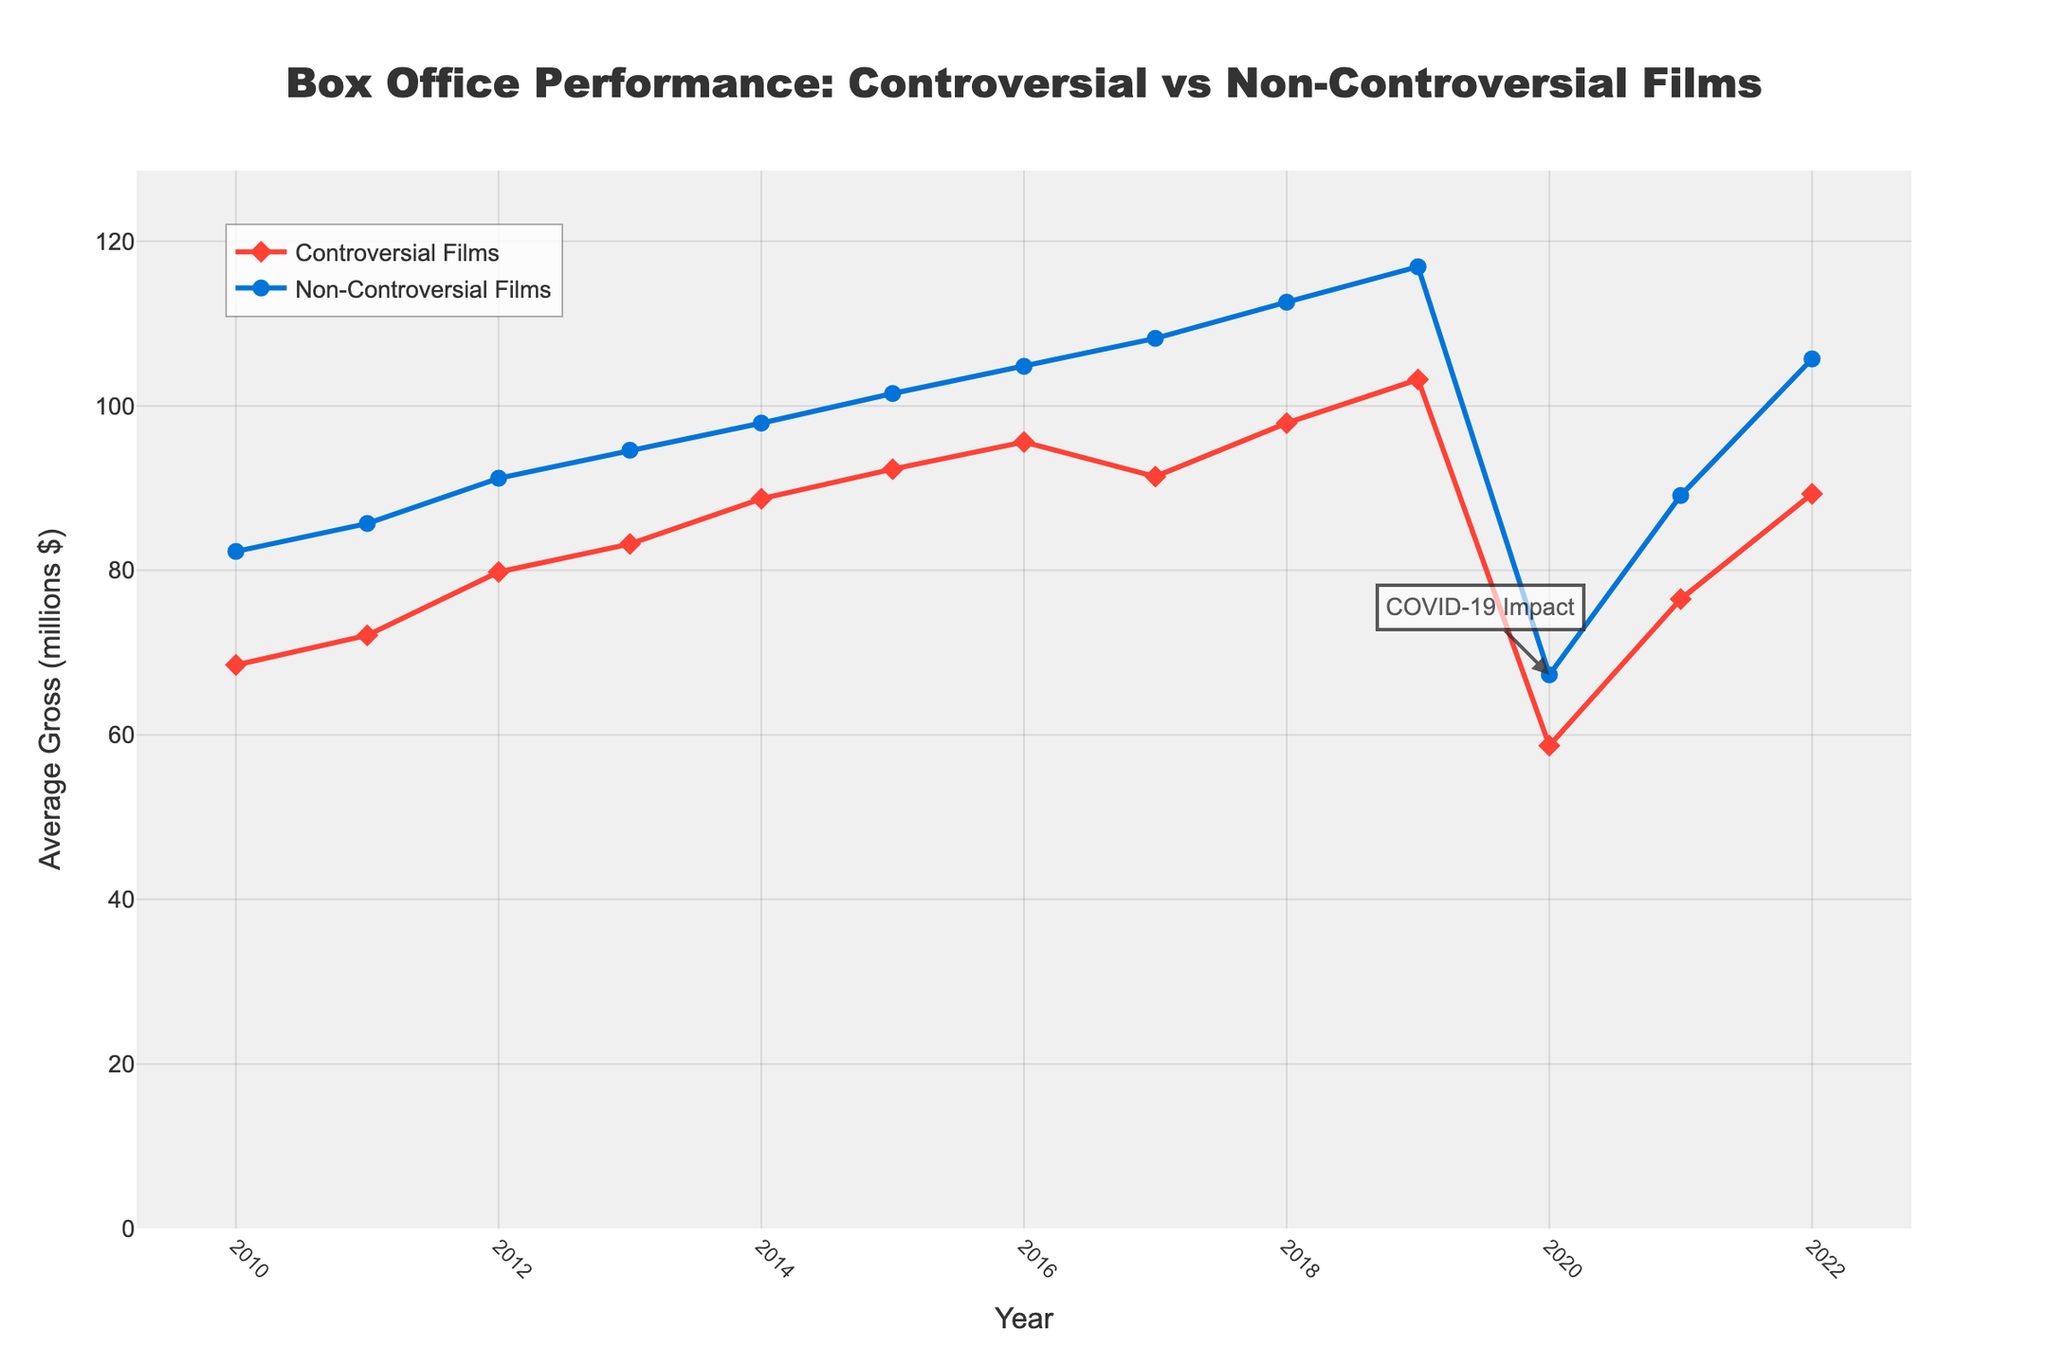What year do both Controversial Films and Non-Controversial Films have the lowest average gross? From the plot, the lowest average gross for both Controversial and Non-Controversial Films occurs in 2020, associated with the "COVID-19 Impact" annotation.
Answer: 2020 In which year is the difference between the average gross of Controversial Films and Non-Controversial Films the smallest? To find the year with the smallest difference, compare the gaps between the lines visually. The differences are relatively smaller from 2010 to 2012, with 2010 having the smallest difference.
Answer: 2010 What is the average gross of Controversial Films in 2019, and how does it compare to 2022? The plot shows that the average gross of Controversial Films in 2019 is around $103.2 million, and in 2022 it is around $89.3 million. Comparing them, 2019 is higher.
Answer: 2019: $103.2M, 2022: $89.3M How does the trend of Non-Controversial Films' average gross change from 2011 to 2013? From 2011 to 2013, the plot shows a consistent upward trend in the average gross of Non-Controversial Films. Specifically, it increases from $85.7 million in 2011 to $94.6 million in 2013.
Answer: Increases What is the approximate percentage decrease in Controversial Films' average gross from 2019 to 2020? The average gross for Controversial Films in 2019 is about $103.2 million and in 2020 it is around $58.7 million. The percentage decrease is calculated as ((103.2 - 58.7) / 103.2) * 100. This results in approximately 43%.
Answer: ~43% Which film category shows a greater recovery in average gross from 2020 to 2022? From the plot, the average gross for Controversial Films increases from $58.7 million in 2020 to $89.3 million in 2022, and Non-Controversial Films increase from $67.3 million to $105.7 million in the same period. In terms of absolute increase, Non-Controversial Films have a larger recovery ($38.4 million vs. $30.6 million).
Answer: Non-Controversial Films During which year is the average gross of Non-Controversial Films closest to $100 million? From the plot, the average gross of Non-Controversial Films is closest to $100 million in 2015, where it is around $101.5 million.
Answer: 2015 Is there any year where Controversial Films' average gross appears to slightly decline before rising again? According to the plot, there is a slight decline in the average gross of Controversial Films from 2016 ($95.6 million) to 2017 ($91.4 million) before it rises again in the subsequent years.
Answer: 2017 